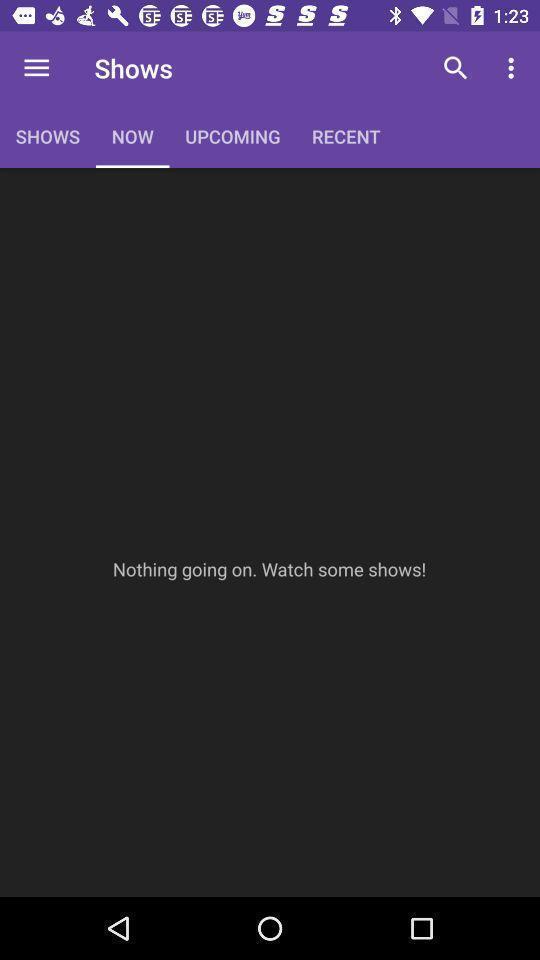Tell me about the visual elements in this screen capture. Page displaying the information of a movies app. 